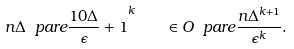<formula> <loc_0><loc_0><loc_500><loc_500>n \Delta \ p a r e { \frac { 1 0 \Delta } { \epsilon } + 1 } ^ { k } \quad \in O \ p a r e { \frac { n \Delta ^ { k + 1 } } { \epsilon ^ { k } } } .</formula> 